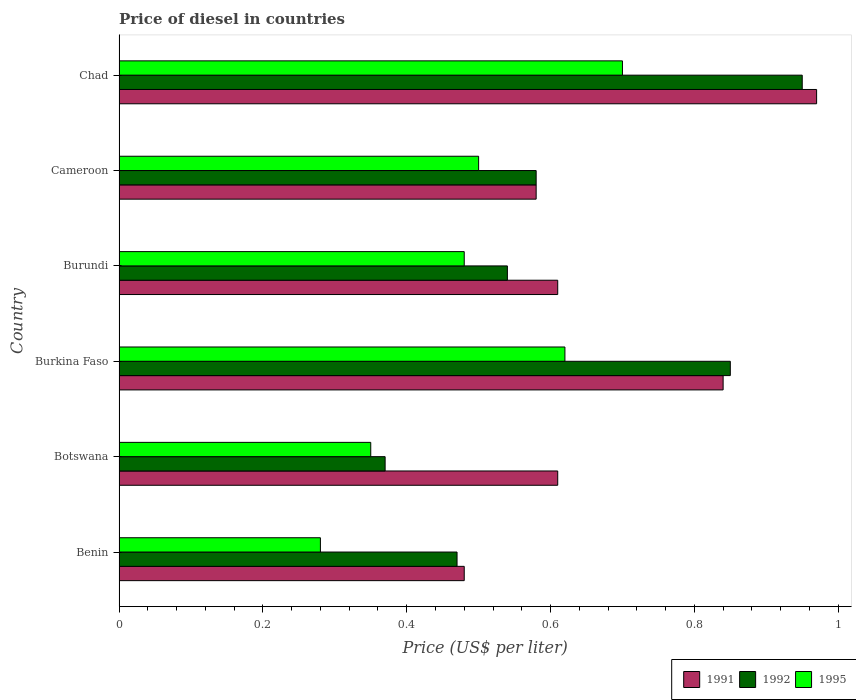How many groups of bars are there?
Your response must be concise. 6. What is the label of the 2nd group of bars from the top?
Offer a terse response. Cameroon. What is the price of diesel in 1991 in Botswana?
Keep it short and to the point. 0.61. Across all countries, what is the minimum price of diesel in 1995?
Offer a very short reply. 0.28. In which country was the price of diesel in 1992 maximum?
Your answer should be very brief. Chad. In which country was the price of diesel in 1991 minimum?
Give a very brief answer. Benin. What is the total price of diesel in 1995 in the graph?
Provide a short and direct response. 2.93. What is the difference between the price of diesel in 1991 in Burundi and that in Cameroon?
Keep it short and to the point. 0.03. What is the difference between the price of diesel in 1992 in Burkina Faso and the price of diesel in 1991 in Botswana?
Offer a very short reply. 0.24. What is the average price of diesel in 1991 per country?
Offer a very short reply. 0.68. What is the difference between the price of diesel in 1992 and price of diesel in 1995 in Burkina Faso?
Give a very brief answer. 0.23. In how many countries, is the price of diesel in 1995 greater than 0.88 US$?
Provide a succinct answer. 0. What is the ratio of the price of diesel in 1991 in Burundi to that in Cameroon?
Your answer should be very brief. 1.05. What is the difference between the highest and the second highest price of diesel in 1995?
Make the answer very short. 0.08. What is the difference between the highest and the lowest price of diesel in 1992?
Provide a short and direct response. 0.58. In how many countries, is the price of diesel in 1991 greater than the average price of diesel in 1991 taken over all countries?
Your answer should be very brief. 2. What does the 2nd bar from the top in Chad represents?
Your answer should be compact. 1992. What does the 1st bar from the bottom in Cameroon represents?
Offer a terse response. 1991. How many bars are there?
Ensure brevity in your answer.  18. How many countries are there in the graph?
Ensure brevity in your answer.  6. Are the values on the major ticks of X-axis written in scientific E-notation?
Your response must be concise. No. Does the graph contain any zero values?
Give a very brief answer. No. How many legend labels are there?
Provide a succinct answer. 3. How are the legend labels stacked?
Make the answer very short. Horizontal. What is the title of the graph?
Your answer should be compact. Price of diesel in countries. What is the label or title of the X-axis?
Provide a short and direct response. Price (US$ per liter). What is the Price (US$ per liter) in 1991 in Benin?
Provide a succinct answer. 0.48. What is the Price (US$ per liter) of 1992 in Benin?
Your answer should be compact. 0.47. What is the Price (US$ per liter) of 1995 in Benin?
Provide a succinct answer. 0.28. What is the Price (US$ per liter) in 1991 in Botswana?
Provide a succinct answer. 0.61. What is the Price (US$ per liter) of 1992 in Botswana?
Your answer should be very brief. 0.37. What is the Price (US$ per liter) in 1991 in Burkina Faso?
Your answer should be very brief. 0.84. What is the Price (US$ per liter) of 1995 in Burkina Faso?
Provide a short and direct response. 0.62. What is the Price (US$ per liter) of 1991 in Burundi?
Provide a succinct answer. 0.61. What is the Price (US$ per liter) of 1992 in Burundi?
Ensure brevity in your answer.  0.54. What is the Price (US$ per liter) in 1995 in Burundi?
Make the answer very short. 0.48. What is the Price (US$ per liter) in 1991 in Cameroon?
Offer a very short reply. 0.58. What is the Price (US$ per liter) in 1992 in Cameroon?
Make the answer very short. 0.58. What is the Price (US$ per liter) in 1995 in Cameroon?
Give a very brief answer. 0.5. What is the Price (US$ per liter) of 1991 in Chad?
Provide a succinct answer. 0.97. Across all countries, what is the maximum Price (US$ per liter) of 1992?
Provide a short and direct response. 0.95. Across all countries, what is the maximum Price (US$ per liter) of 1995?
Give a very brief answer. 0.7. Across all countries, what is the minimum Price (US$ per liter) of 1991?
Keep it short and to the point. 0.48. Across all countries, what is the minimum Price (US$ per liter) of 1992?
Your answer should be compact. 0.37. Across all countries, what is the minimum Price (US$ per liter) of 1995?
Provide a succinct answer. 0.28. What is the total Price (US$ per liter) of 1991 in the graph?
Ensure brevity in your answer.  4.09. What is the total Price (US$ per liter) in 1992 in the graph?
Provide a short and direct response. 3.76. What is the total Price (US$ per liter) of 1995 in the graph?
Make the answer very short. 2.93. What is the difference between the Price (US$ per liter) of 1991 in Benin and that in Botswana?
Ensure brevity in your answer.  -0.13. What is the difference between the Price (US$ per liter) in 1995 in Benin and that in Botswana?
Provide a succinct answer. -0.07. What is the difference between the Price (US$ per liter) of 1991 in Benin and that in Burkina Faso?
Offer a very short reply. -0.36. What is the difference between the Price (US$ per liter) of 1992 in Benin and that in Burkina Faso?
Make the answer very short. -0.38. What is the difference between the Price (US$ per liter) of 1995 in Benin and that in Burkina Faso?
Make the answer very short. -0.34. What is the difference between the Price (US$ per liter) of 1991 in Benin and that in Burundi?
Provide a succinct answer. -0.13. What is the difference between the Price (US$ per liter) in 1992 in Benin and that in Burundi?
Provide a succinct answer. -0.07. What is the difference between the Price (US$ per liter) in 1991 in Benin and that in Cameroon?
Provide a short and direct response. -0.1. What is the difference between the Price (US$ per liter) in 1992 in Benin and that in Cameroon?
Your answer should be very brief. -0.11. What is the difference between the Price (US$ per liter) of 1995 in Benin and that in Cameroon?
Provide a succinct answer. -0.22. What is the difference between the Price (US$ per liter) of 1991 in Benin and that in Chad?
Make the answer very short. -0.49. What is the difference between the Price (US$ per liter) in 1992 in Benin and that in Chad?
Your answer should be very brief. -0.48. What is the difference between the Price (US$ per liter) in 1995 in Benin and that in Chad?
Make the answer very short. -0.42. What is the difference between the Price (US$ per liter) of 1991 in Botswana and that in Burkina Faso?
Give a very brief answer. -0.23. What is the difference between the Price (US$ per liter) of 1992 in Botswana and that in Burkina Faso?
Give a very brief answer. -0.48. What is the difference between the Price (US$ per liter) in 1995 in Botswana and that in Burkina Faso?
Your answer should be very brief. -0.27. What is the difference between the Price (US$ per liter) in 1991 in Botswana and that in Burundi?
Offer a very short reply. 0. What is the difference between the Price (US$ per liter) in 1992 in Botswana and that in Burundi?
Ensure brevity in your answer.  -0.17. What is the difference between the Price (US$ per liter) in 1995 in Botswana and that in Burundi?
Your answer should be compact. -0.13. What is the difference between the Price (US$ per liter) of 1992 in Botswana and that in Cameroon?
Offer a terse response. -0.21. What is the difference between the Price (US$ per liter) of 1995 in Botswana and that in Cameroon?
Make the answer very short. -0.15. What is the difference between the Price (US$ per liter) of 1991 in Botswana and that in Chad?
Your response must be concise. -0.36. What is the difference between the Price (US$ per liter) of 1992 in Botswana and that in Chad?
Give a very brief answer. -0.58. What is the difference between the Price (US$ per liter) of 1995 in Botswana and that in Chad?
Offer a terse response. -0.35. What is the difference between the Price (US$ per liter) of 1991 in Burkina Faso and that in Burundi?
Your response must be concise. 0.23. What is the difference between the Price (US$ per liter) of 1992 in Burkina Faso and that in Burundi?
Your response must be concise. 0.31. What is the difference between the Price (US$ per liter) in 1995 in Burkina Faso and that in Burundi?
Give a very brief answer. 0.14. What is the difference between the Price (US$ per liter) of 1991 in Burkina Faso and that in Cameroon?
Make the answer very short. 0.26. What is the difference between the Price (US$ per liter) of 1992 in Burkina Faso and that in Cameroon?
Your response must be concise. 0.27. What is the difference between the Price (US$ per liter) in 1995 in Burkina Faso and that in Cameroon?
Offer a very short reply. 0.12. What is the difference between the Price (US$ per liter) of 1991 in Burkina Faso and that in Chad?
Provide a succinct answer. -0.13. What is the difference between the Price (US$ per liter) of 1992 in Burkina Faso and that in Chad?
Your answer should be very brief. -0.1. What is the difference between the Price (US$ per liter) in 1995 in Burkina Faso and that in Chad?
Make the answer very short. -0.08. What is the difference between the Price (US$ per liter) in 1991 in Burundi and that in Cameroon?
Provide a succinct answer. 0.03. What is the difference between the Price (US$ per liter) of 1992 in Burundi and that in Cameroon?
Offer a very short reply. -0.04. What is the difference between the Price (US$ per liter) in 1995 in Burundi and that in Cameroon?
Make the answer very short. -0.02. What is the difference between the Price (US$ per liter) in 1991 in Burundi and that in Chad?
Provide a succinct answer. -0.36. What is the difference between the Price (US$ per liter) of 1992 in Burundi and that in Chad?
Keep it short and to the point. -0.41. What is the difference between the Price (US$ per liter) in 1995 in Burundi and that in Chad?
Provide a short and direct response. -0.22. What is the difference between the Price (US$ per liter) in 1991 in Cameroon and that in Chad?
Make the answer very short. -0.39. What is the difference between the Price (US$ per liter) in 1992 in Cameroon and that in Chad?
Provide a succinct answer. -0.37. What is the difference between the Price (US$ per liter) in 1995 in Cameroon and that in Chad?
Make the answer very short. -0.2. What is the difference between the Price (US$ per liter) in 1991 in Benin and the Price (US$ per liter) in 1992 in Botswana?
Your answer should be very brief. 0.11. What is the difference between the Price (US$ per liter) in 1991 in Benin and the Price (US$ per liter) in 1995 in Botswana?
Give a very brief answer. 0.13. What is the difference between the Price (US$ per liter) of 1992 in Benin and the Price (US$ per liter) of 1995 in Botswana?
Your response must be concise. 0.12. What is the difference between the Price (US$ per liter) of 1991 in Benin and the Price (US$ per liter) of 1992 in Burkina Faso?
Offer a terse response. -0.37. What is the difference between the Price (US$ per liter) in 1991 in Benin and the Price (US$ per liter) in 1995 in Burkina Faso?
Provide a succinct answer. -0.14. What is the difference between the Price (US$ per liter) of 1992 in Benin and the Price (US$ per liter) of 1995 in Burkina Faso?
Provide a short and direct response. -0.15. What is the difference between the Price (US$ per liter) of 1991 in Benin and the Price (US$ per liter) of 1992 in Burundi?
Offer a terse response. -0.06. What is the difference between the Price (US$ per liter) in 1991 in Benin and the Price (US$ per liter) in 1995 in Burundi?
Offer a terse response. 0. What is the difference between the Price (US$ per liter) of 1992 in Benin and the Price (US$ per liter) of 1995 in Burundi?
Offer a terse response. -0.01. What is the difference between the Price (US$ per liter) of 1991 in Benin and the Price (US$ per liter) of 1995 in Cameroon?
Ensure brevity in your answer.  -0.02. What is the difference between the Price (US$ per liter) in 1992 in Benin and the Price (US$ per liter) in 1995 in Cameroon?
Make the answer very short. -0.03. What is the difference between the Price (US$ per liter) of 1991 in Benin and the Price (US$ per liter) of 1992 in Chad?
Provide a succinct answer. -0.47. What is the difference between the Price (US$ per liter) of 1991 in Benin and the Price (US$ per liter) of 1995 in Chad?
Provide a short and direct response. -0.22. What is the difference between the Price (US$ per liter) of 1992 in Benin and the Price (US$ per liter) of 1995 in Chad?
Give a very brief answer. -0.23. What is the difference between the Price (US$ per liter) of 1991 in Botswana and the Price (US$ per liter) of 1992 in Burkina Faso?
Your answer should be compact. -0.24. What is the difference between the Price (US$ per liter) in 1991 in Botswana and the Price (US$ per liter) in 1995 in Burkina Faso?
Your answer should be compact. -0.01. What is the difference between the Price (US$ per liter) of 1991 in Botswana and the Price (US$ per liter) of 1992 in Burundi?
Provide a short and direct response. 0.07. What is the difference between the Price (US$ per liter) of 1991 in Botswana and the Price (US$ per liter) of 1995 in Burundi?
Ensure brevity in your answer.  0.13. What is the difference between the Price (US$ per liter) of 1992 in Botswana and the Price (US$ per liter) of 1995 in Burundi?
Provide a short and direct response. -0.11. What is the difference between the Price (US$ per liter) of 1991 in Botswana and the Price (US$ per liter) of 1992 in Cameroon?
Provide a succinct answer. 0.03. What is the difference between the Price (US$ per liter) of 1991 in Botswana and the Price (US$ per liter) of 1995 in Cameroon?
Give a very brief answer. 0.11. What is the difference between the Price (US$ per liter) of 1992 in Botswana and the Price (US$ per liter) of 1995 in Cameroon?
Provide a short and direct response. -0.13. What is the difference between the Price (US$ per liter) in 1991 in Botswana and the Price (US$ per liter) in 1992 in Chad?
Provide a short and direct response. -0.34. What is the difference between the Price (US$ per liter) of 1991 in Botswana and the Price (US$ per liter) of 1995 in Chad?
Offer a very short reply. -0.09. What is the difference between the Price (US$ per liter) of 1992 in Botswana and the Price (US$ per liter) of 1995 in Chad?
Your answer should be compact. -0.33. What is the difference between the Price (US$ per liter) of 1991 in Burkina Faso and the Price (US$ per liter) of 1995 in Burundi?
Offer a terse response. 0.36. What is the difference between the Price (US$ per liter) in 1992 in Burkina Faso and the Price (US$ per liter) in 1995 in Burundi?
Your answer should be very brief. 0.37. What is the difference between the Price (US$ per liter) of 1991 in Burkina Faso and the Price (US$ per liter) of 1992 in Cameroon?
Offer a terse response. 0.26. What is the difference between the Price (US$ per liter) of 1991 in Burkina Faso and the Price (US$ per liter) of 1995 in Cameroon?
Give a very brief answer. 0.34. What is the difference between the Price (US$ per liter) in 1992 in Burkina Faso and the Price (US$ per liter) in 1995 in Cameroon?
Keep it short and to the point. 0.35. What is the difference between the Price (US$ per liter) in 1991 in Burkina Faso and the Price (US$ per liter) in 1992 in Chad?
Provide a short and direct response. -0.11. What is the difference between the Price (US$ per liter) of 1991 in Burkina Faso and the Price (US$ per liter) of 1995 in Chad?
Your response must be concise. 0.14. What is the difference between the Price (US$ per liter) of 1992 in Burkina Faso and the Price (US$ per liter) of 1995 in Chad?
Provide a short and direct response. 0.15. What is the difference between the Price (US$ per liter) in 1991 in Burundi and the Price (US$ per liter) in 1992 in Cameroon?
Make the answer very short. 0.03. What is the difference between the Price (US$ per liter) in 1991 in Burundi and the Price (US$ per liter) in 1995 in Cameroon?
Offer a very short reply. 0.11. What is the difference between the Price (US$ per liter) in 1991 in Burundi and the Price (US$ per liter) in 1992 in Chad?
Ensure brevity in your answer.  -0.34. What is the difference between the Price (US$ per liter) of 1991 in Burundi and the Price (US$ per liter) of 1995 in Chad?
Offer a very short reply. -0.09. What is the difference between the Price (US$ per liter) in 1992 in Burundi and the Price (US$ per liter) in 1995 in Chad?
Offer a very short reply. -0.16. What is the difference between the Price (US$ per liter) of 1991 in Cameroon and the Price (US$ per liter) of 1992 in Chad?
Give a very brief answer. -0.37. What is the difference between the Price (US$ per liter) of 1991 in Cameroon and the Price (US$ per liter) of 1995 in Chad?
Keep it short and to the point. -0.12. What is the difference between the Price (US$ per liter) in 1992 in Cameroon and the Price (US$ per liter) in 1995 in Chad?
Your response must be concise. -0.12. What is the average Price (US$ per liter) in 1991 per country?
Keep it short and to the point. 0.68. What is the average Price (US$ per liter) in 1992 per country?
Offer a terse response. 0.63. What is the average Price (US$ per liter) of 1995 per country?
Make the answer very short. 0.49. What is the difference between the Price (US$ per liter) in 1992 and Price (US$ per liter) in 1995 in Benin?
Keep it short and to the point. 0.19. What is the difference between the Price (US$ per liter) in 1991 and Price (US$ per liter) in 1992 in Botswana?
Your answer should be compact. 0.24. What is the difference between the Price (US$ per liter) in 1991 and Price (US$ per liter) in 1995 in Botswana?
Your answer should be very brief. 0.26. What is the difference between the Price (US$ per liter) of 1991 and Price (US$ per liter) of 1992 in Burkina Faso?
Give a very brief answer. -0.01. What is the difference between the Price (US$ per liter) of 1991 and Price (US$ per liter) of 1995 in Burkina Faso?
Ensure brevity in your answer.  0.22. What is the difference between the Price (US$ per liter) in 1992 and Price (US$ per liter) in 1995 in Burkina Faso?
Offer a very short reply. 0.23. What is the difference between the Price (US$ per liter) in 1991 and Price (US$ per liter) in 1992 in Burundi?
Provide a succinct answer. 0.07. What is the difference between the Price (US$ per liter) in 1991 and Price (US$ per liter) in 1995 in Burundi?
Your answer should be compact. 0.13. What is the difference between the Price (US$ per liter) in 1992 and Price (US$ per liter) in 1995 in Burundi?
Offer a very short reply. 0.06. What is the difference between the Price (US$ per liter) of 1991 and Price (US$ per liter) of 1992 in Cameroon?
Provide a succinct answer. 0. What is the difference between the Price (US$ per liter) of 1991 and Price (US$ per liter) of 1992 in Chad?
Your answer should be compact. 0.02. What is the difference between the Price (US$ per liter) of 1991 and Price (US$ per liter) of 1995 in Chad?
Offer a very short reply. 0.27. What is the difference between the Price (US$ per liter) of 1992 and Price (US$ per liter) of 1995 in Chad?
Make the answer very short. 0.25. What is the ratio of the Price (US$ per liter) of 1991 in Benin to that in Botswana?
Your answer should be compact. 0.79. What is the ratio of the Price (US$ per liter) in 1992 in Benin to that in Botswana?
Offer a terse response. 1.27. What is the ratio of the Price (US$ per liter) of 1992 in Benin to that in Burkina Faso?
Offer a terse response. 0.55. What is the ratio of the Price (US$ per liter) of 1995 in Benin to that in Burkina Faso?
Provide a short and direct response. 0.45. What is the ratio of the Price (US$ per liter) in 1991 in Benin to that in Burundi?
Your answer should be very brief. 0.79. What is the ratio of the Price (US$ per liter) in 1992 in Benin to that in Burundi?
Provide a short and direct response. 0.87. What is the ratio of the Price (US$ per liter) of 1995 in Benin to that in Burundi?
Offer a very short reply. 0.58. What is the ratio of the Price (US$ per liter) of 1991 in Benin to that in Cameroon?
Keep it short and to the point. 0.83. What is the ratio of the Price (US$ per liter) of 1992 in Benin to that in Cameroon?
Offer a terse response. 0.81. What is the ratio of the Price (US$ per liter) in 1995 in Benin to that in Cameroon?
Your response must be concise. 0.56. What is the ratio of the Price (US$ per liter) of 1991 in Benin to that in Chad?
Offer a terse response. 0.49. What is the ratio of the Price (US$ per liter) of 1992 in Benin to that in Chad?
Provide a succinct answer. 0.49. What is the ratio of the Price (US$ per liter) of 1991 in Botswana to that in Burkina Faso?
Your answer should be very brief. 0.73. What is the ratio of the Price (US$ per liter) in 1992 in Botswana to that in Burkina Faso?
Offer a very short reply. 0.44. What is the ratio of the Price (US$ per liter) in 1995 in Botswana to that in Burkina Faso?
Offer a very short reply. 0.56. What is the ratio of the Price (US$ per liter) in 1991 in Botswana to that in Burundi?
Give a very brief answer. 1. What is the ratio of the Price (US$ per liter) in 1992 in Botswana to that in Burundi?
Keep it short and to the point. 0.69. What is the ratio of the Price (US$ per liter) in 1995 in Botswana to that in Burundi?
Give a very brief answer. 0.73. What is the ratio of the Price (US$ per liter) of 1991 in Botswana to that in Cameroon?
Your response must be concise. 1.05. What is the ratio of the Price (US$ per liter) in 1992 in Botswana to that in Cameroon?
Your answer should be very brief. 0.64. What is the ratio of the Price (US$ per liter) of 1991 in Botswana to that in Chad?
Make the answer very short. 0.63. What is the ratio of the Price (US$ per liter) in 1992 in Botswana to that in Chad?
Your answer should be compact. 0.39. What is the ratio of the Price (US$ per liter) of 1991 in Burkina Faso to that in Burundi?
Your response must be concise. 1.38. What is the ratio of the Price (US$ per liter) in 1992 in Burkina Faso to that in Burundi?
Your answer should be compact. 1.57. What is the ratio of the Price (US$ per liter) of 1995 in Burkina Faso to that in Burundi?
Offer a very short reply. 1.29. What is the ratio of the Price (US$ per liter) of 1991 in Burkina Faso to that in Cameroon?
Your answer should be very brief. 1.45. What is the ratio of the Price (US$ per liter) in 1992 in Burkina Faso to that in Cameroon?
Offer a terse response. 1.47. What is the ratio of the Price (US$ per liter) of 1995 in Burkina Faso to that in Cameroon?
Offer a very short reply. 1.24. What is the ratio of the Price (US$ per liter) in 1991 in Burkina Faso to that in Chad?
Keep it short and to the point. 0.87. What is the ratio of the Price (US$ per liter) of 1992 in Burkina Faso to that in Chad?
Give a very brief answer. 0.89. What is the ratio of the Price (US$ per liter) in 1995 in Burkina Faso to that in Chad?
Keep it short and to the point. 0.89. What is the ratio of the Price (US$ per liter) in 1991 in Burundi to that in Cameroon?
Give a very brief answer. 1.05. What is the ratio of the Price (US$ per liter) in 1992 in Burundi to that in Cameroon?
Your response must be concise. 0.93. What is the ratio of the Price (US$ per liter) of 1995 in Burundi to that in Cameroon?
Offer a terse response. 0.96. What is the ratio of the Price (US$ per liter) of 1991 in Burundi to that in Chad?
Ensure brevity in your answer.  0.63. What is the ratio of the Price (US$ per liter) of 1992 in Burundi to that in Chad?
Give a very brief answer. 0.57. What is the ratio of the Price (US$ per liter) in 1995 in Burundi to that in Chad?
Make the answer very short. 0.69. What is the ratio of the Price (US$ per liter) in 1991 in Cameroon to that in Chad?
Make the answer very short. 0.6. What is the ratio of the Price (US$ per liter) in 1992 in Cameroon to that in Chad?
Provide a succinct answer. 0.61. What is the difference between the highest and the second highest Price (US$ per liter) in 1991?
Give a very brief answer. 0.13. What is the difference between the highest and the lowest Price (US$ per liter) of 1991?
Offer a terse response. 0.49. What is the difference between the highest and the lowest Price (US$ per liter) of 1992?
Your answer should be compact. 0.58. What is the difference between the highest and the lowest Price (US$ per liter) in 1995?
Your response must be concise. 0.42. 